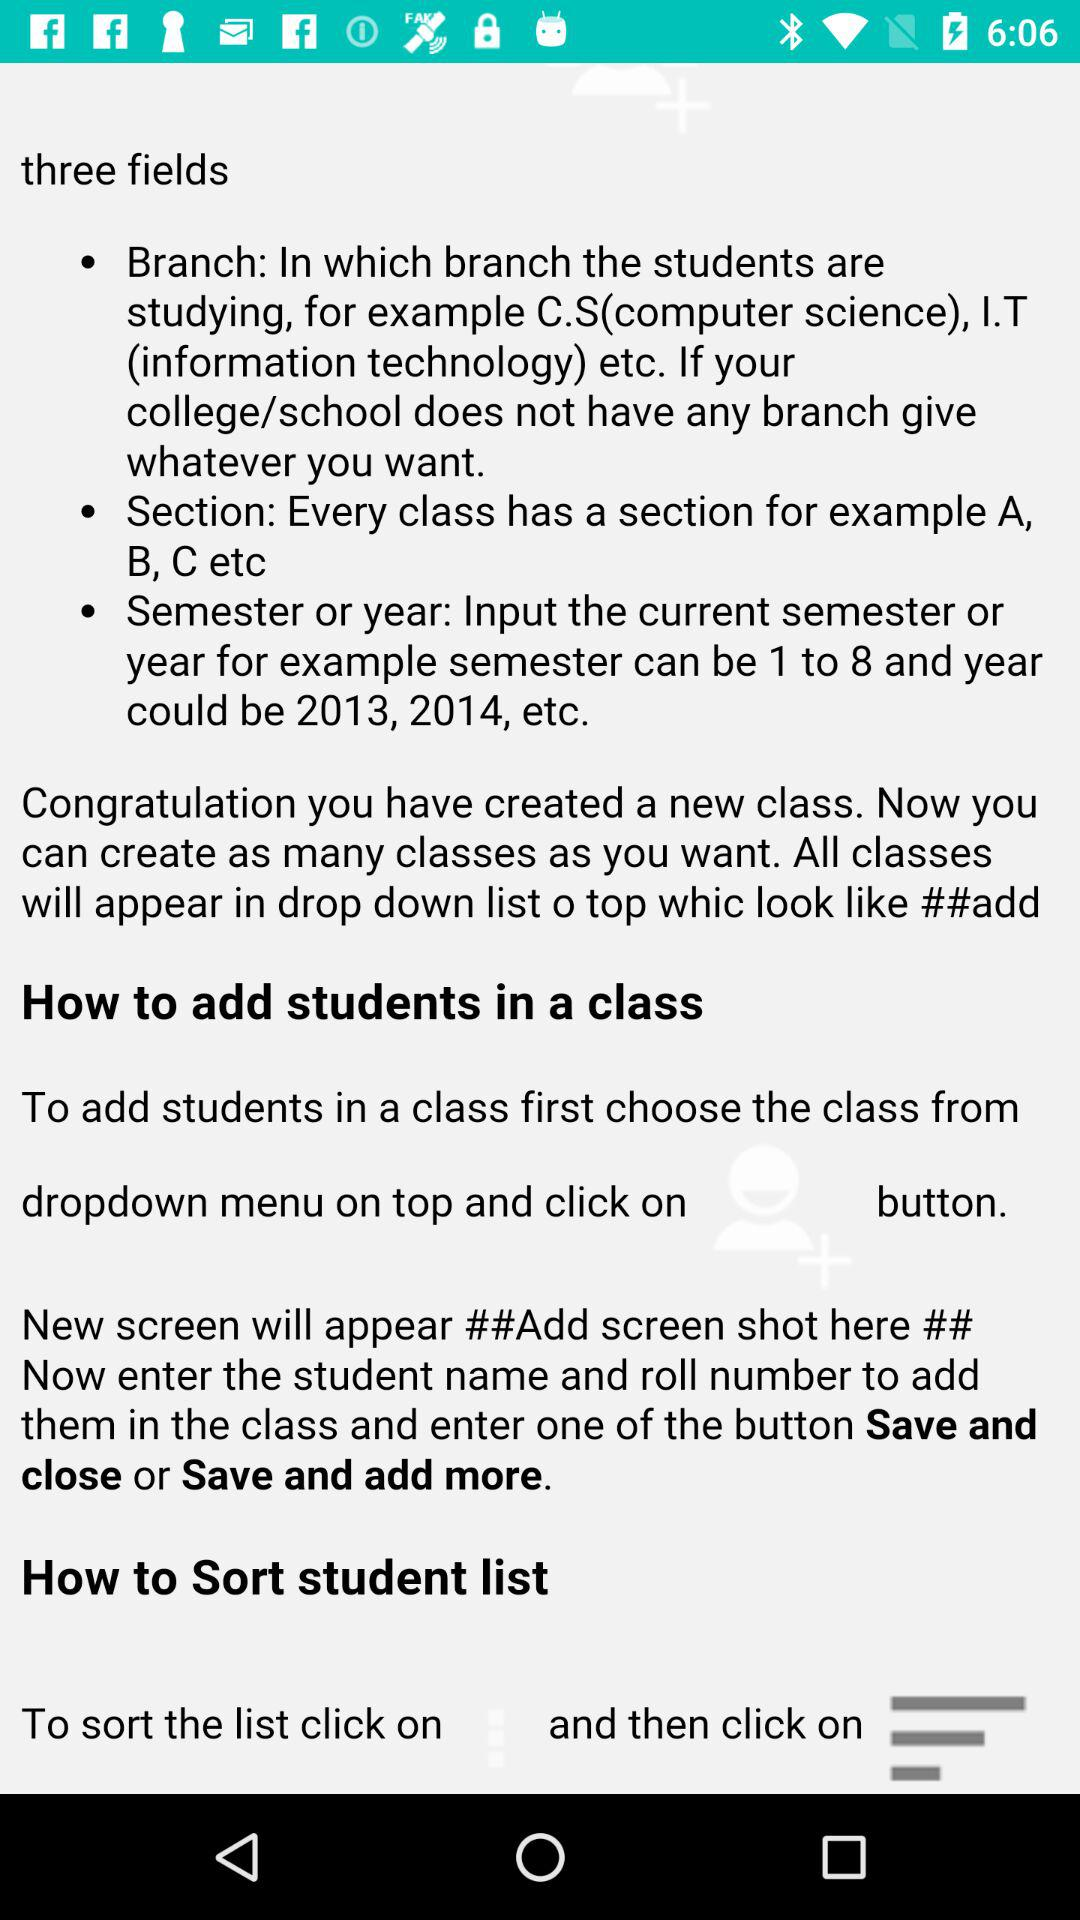What are the three fields required to create a new class? The three fields required to create a new class are "Branch", "Section" and "Semester or year". 